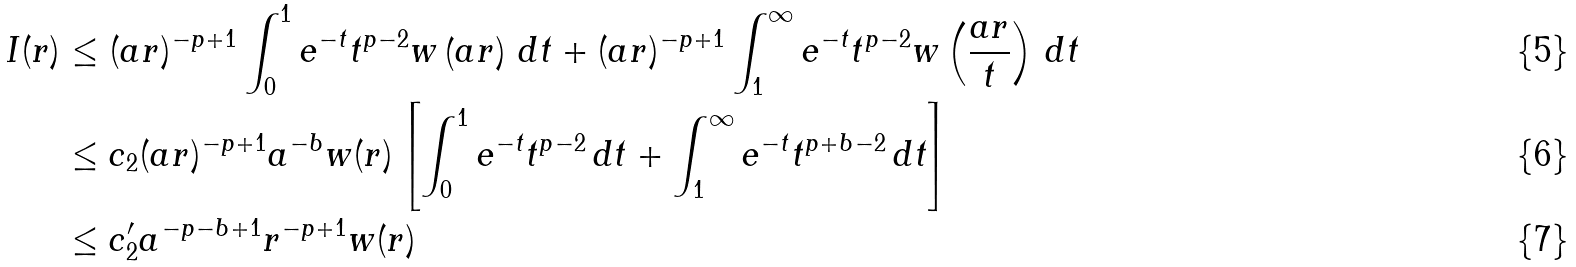<formula> <loc_0><loc_0><loc_500><loc_500>I ( r ) & \leq ( a r ) ^ { - p + 1 } \int _ { 0 } ^ { 1 } e ^ { - t } t ^ { p - 2 } w \left ( a r \right ) \, d t + ( a r ) ^ { - p + 1 } \int _ { 1 } ^ { \infty } e ^ { - t } t ^ { p - 2 } w \left ( \frac { a r } { t } \right ) \, d t \\ & \leq c _ { 2 } ( a r ) ^ { - p + 1 } a ^ { - b } w ( r ) \left [ \int _ { 0 } ^ { 1 } e ^ { - t } t ^ { p - 2 } \, d t + \int _ { 1 } ^ { \infty } e ^ { - t } t ^ { p + b - 2 } \, d t \right ] \\ & \leq c _ { 2 } ^ { \prime } a ^ { - p - b + 1 } r ^ { - p + 1 } w ( r )</formula> 